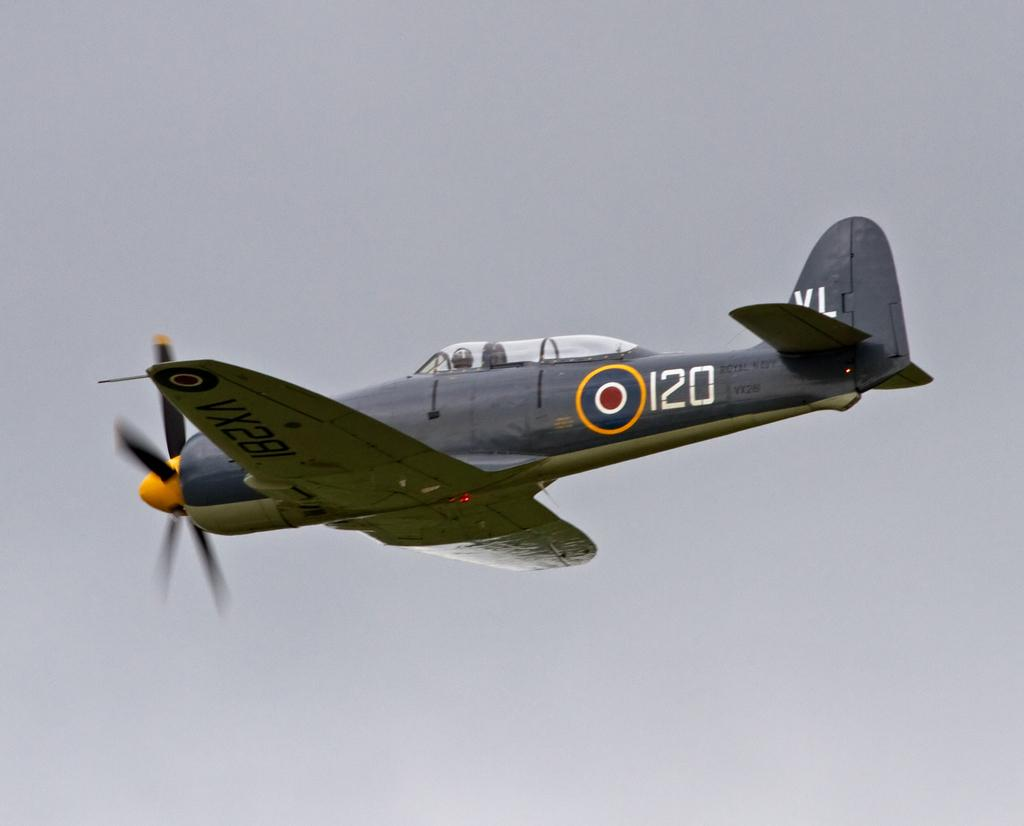<image>
Present a compact description of the photo's key features. A World War II era fighter plane has the number 120 on it. 